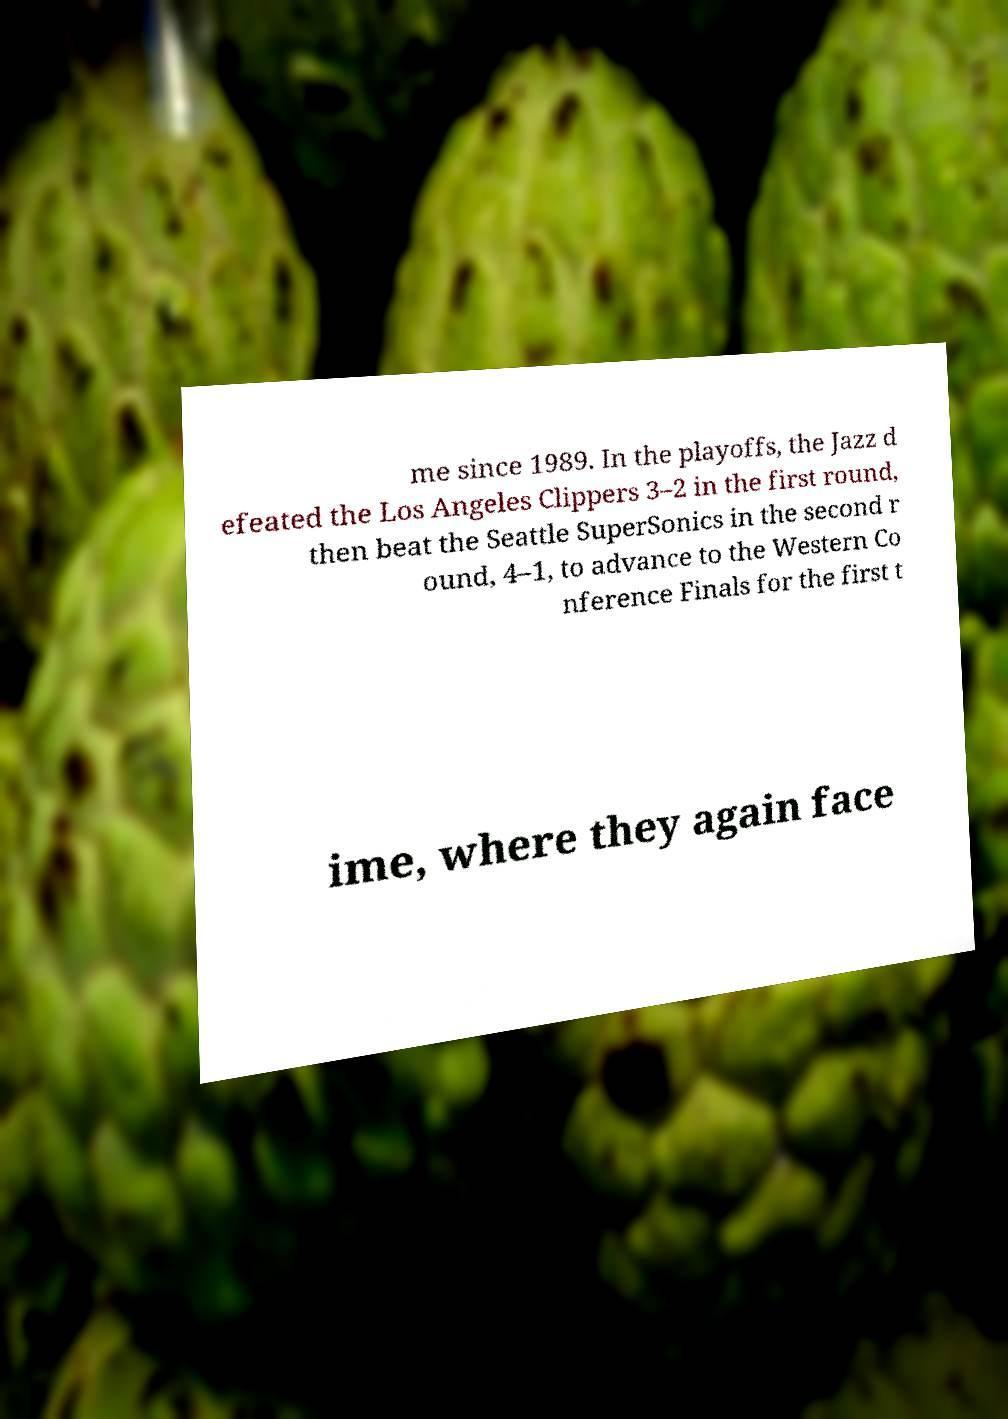There's text embedded in this image that I need extracted. Can you transcribe it verbatim? me since 1989. In the playoffs, the Jazz d efeated the Los Angeles Clippers 3–2 in the first round, then beat the Seattle SuperSonics in the second r ound, 4–1, to advance to the Western Co nference Finals for the first t ime, where they again face 